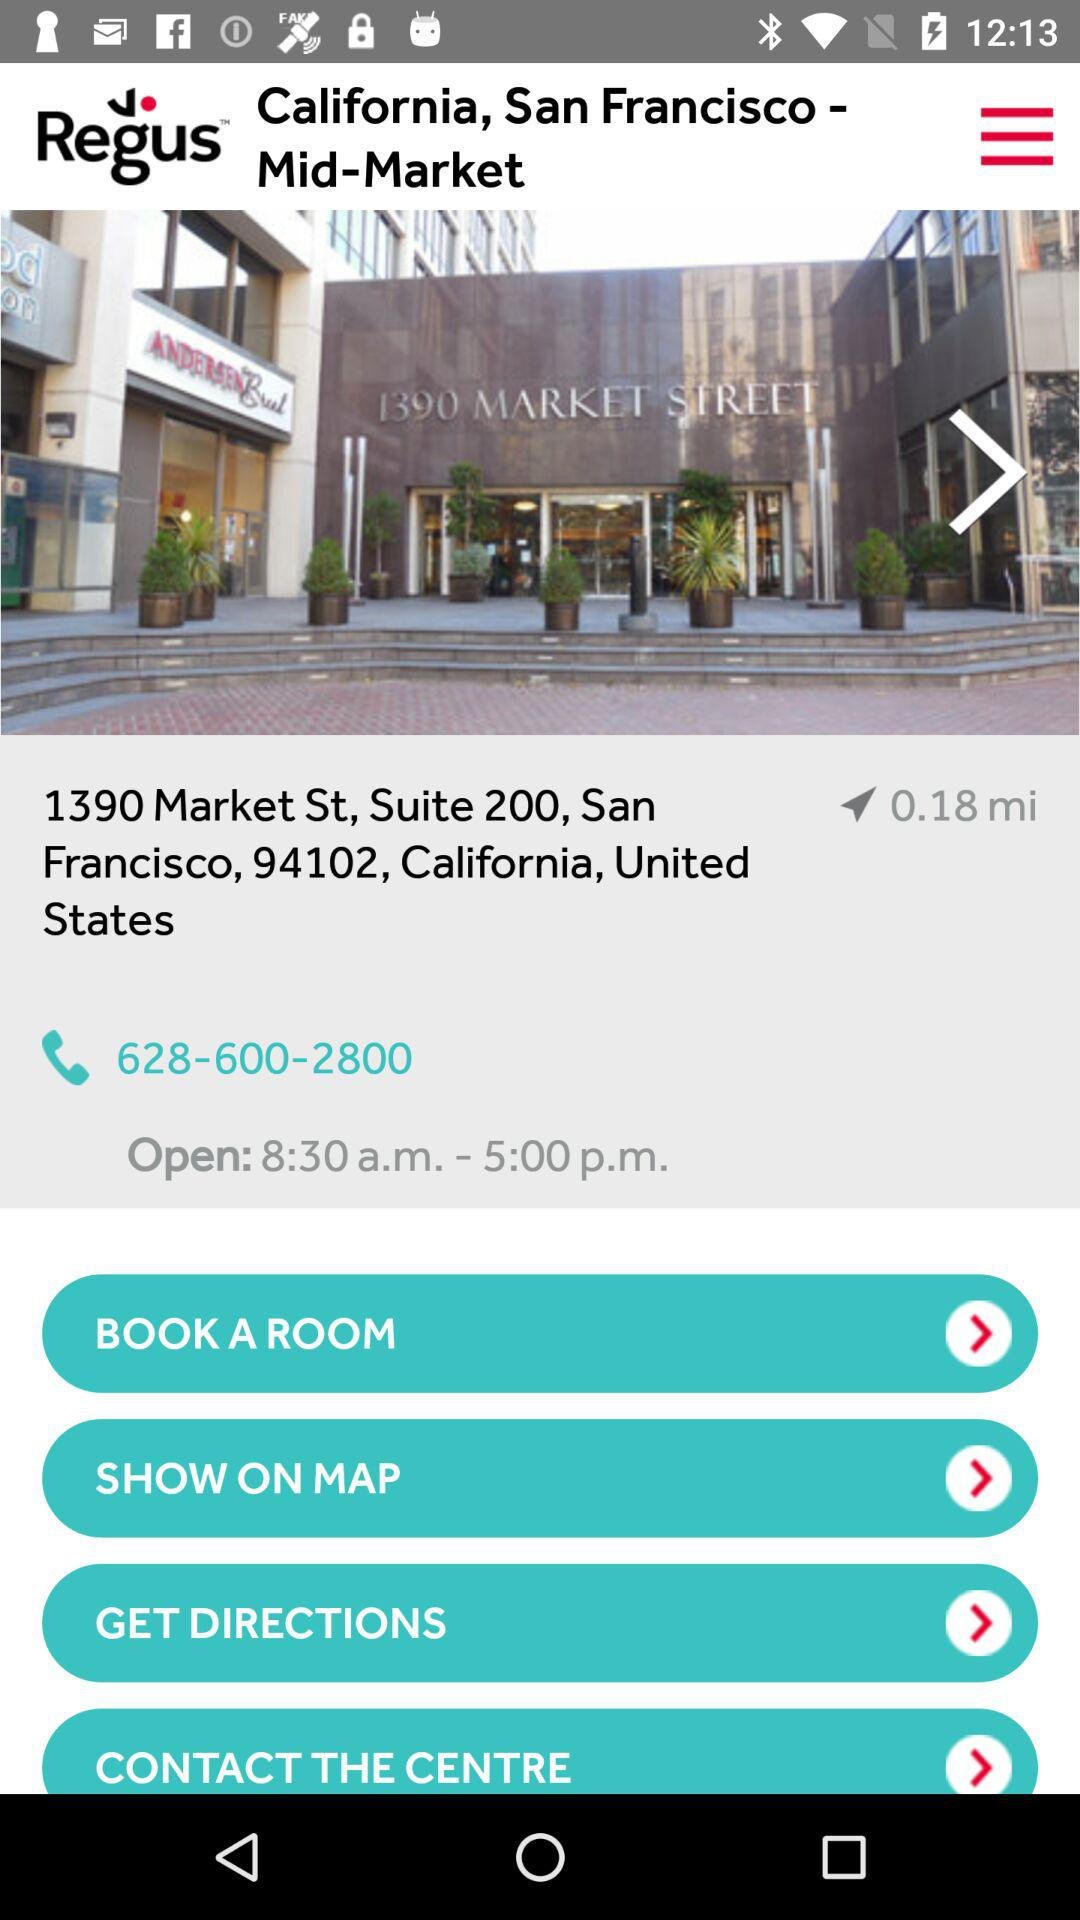What is the company's address? The company's address is 1390 Market St., Suite 200, San Francisco, California, 94102, United States. 